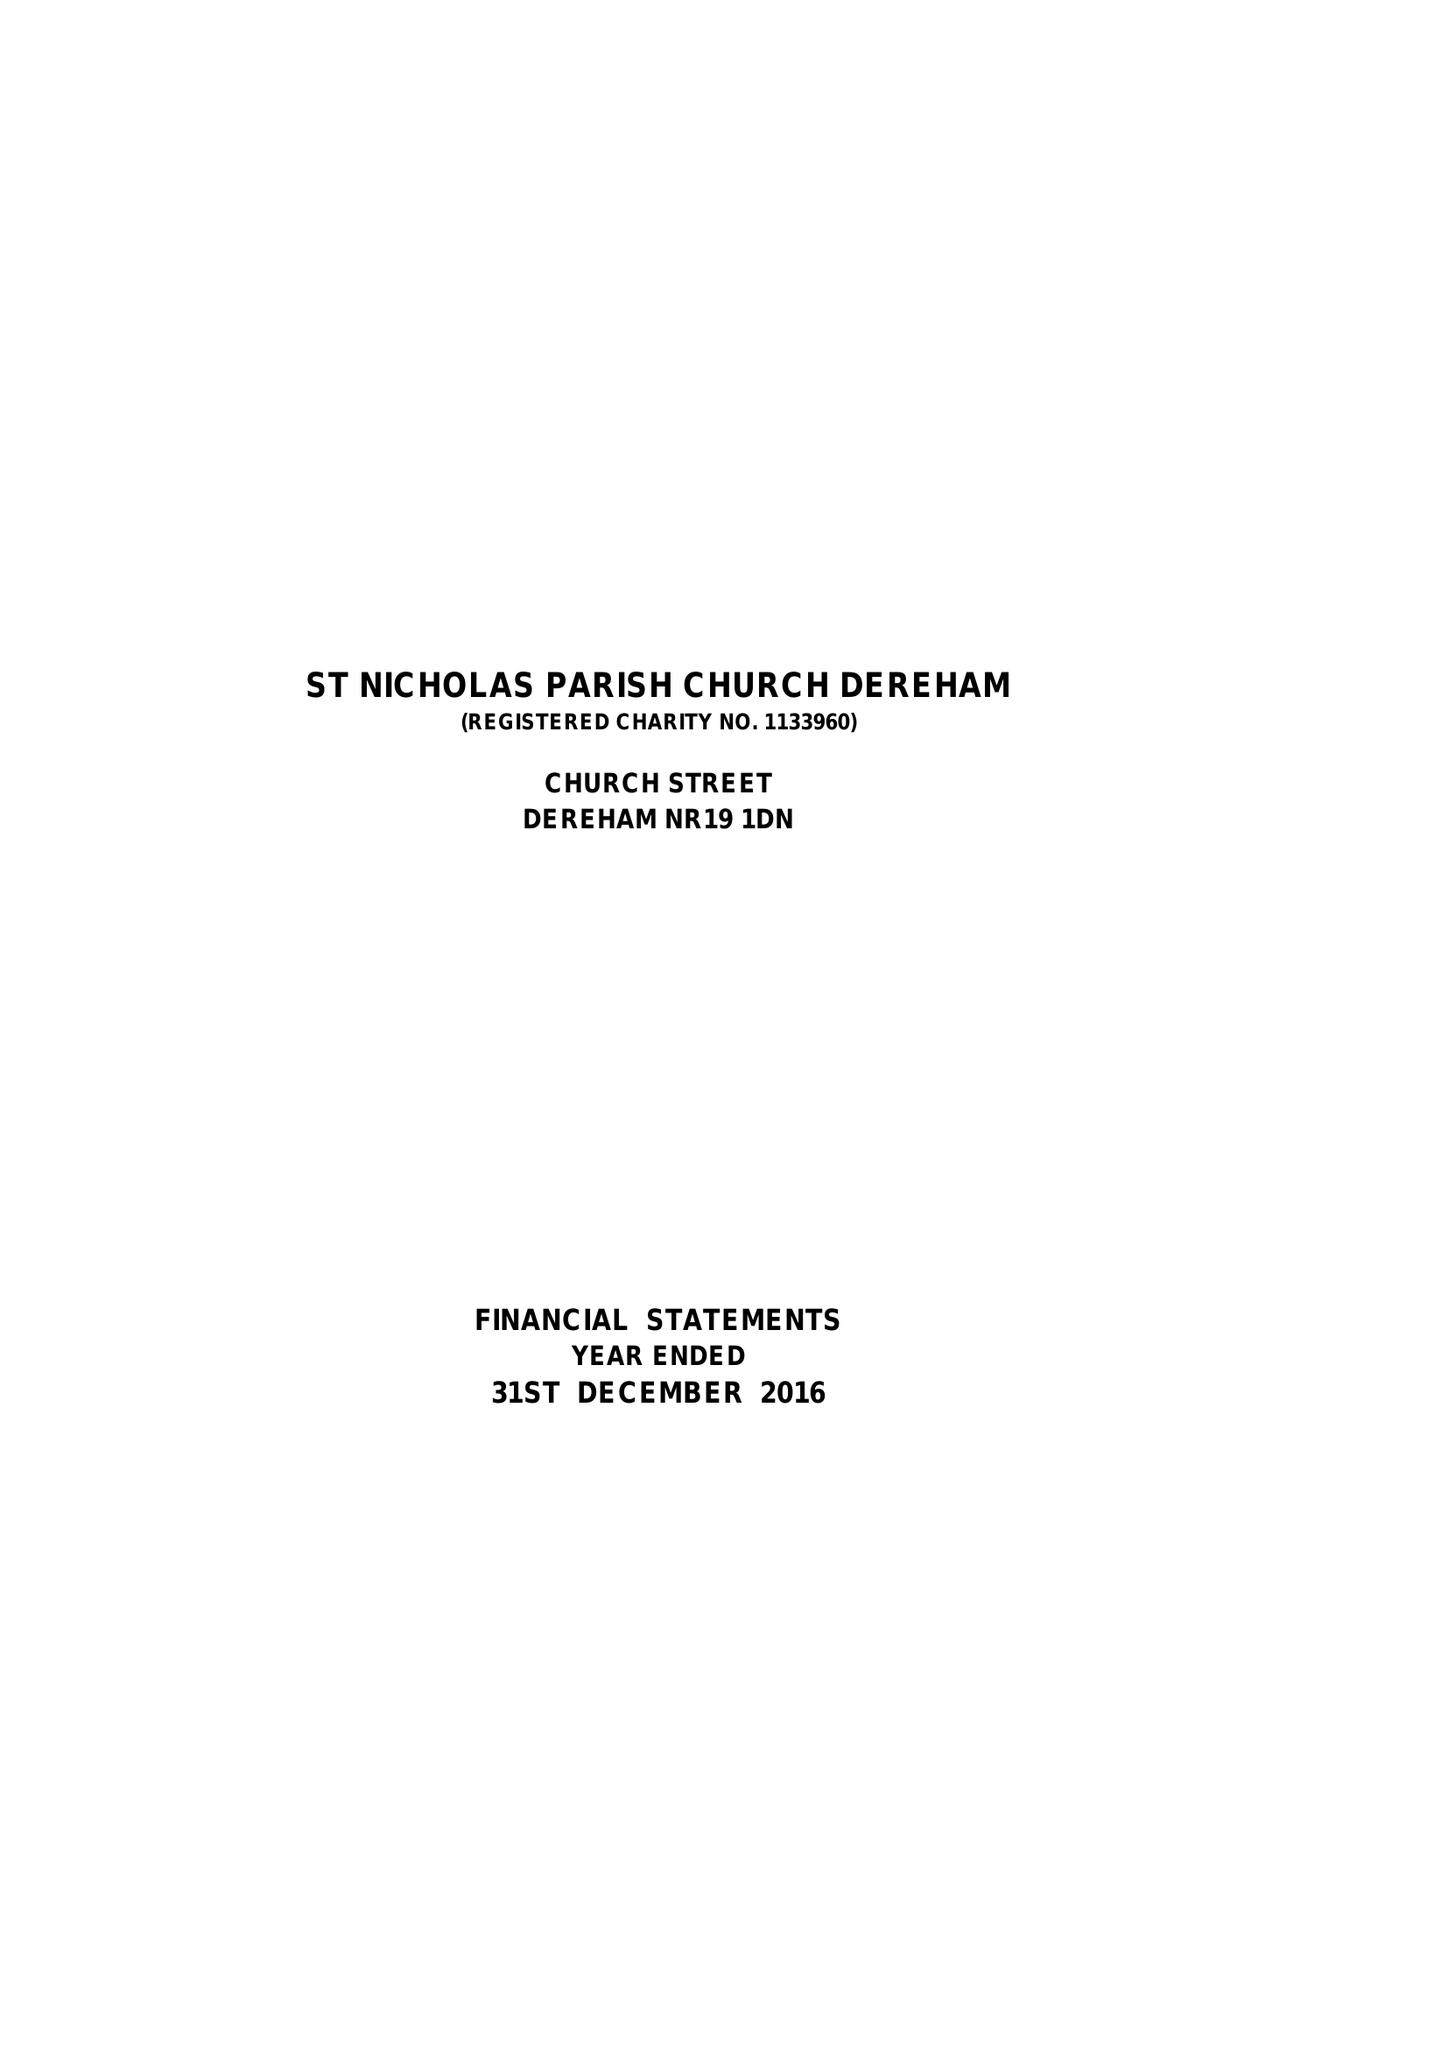What is the value for the charity_name?
Answer the question using a single word or phrase. The Parochial Church Council Of The Ecclesiastical Parish Of St Nicholas, Dereham 